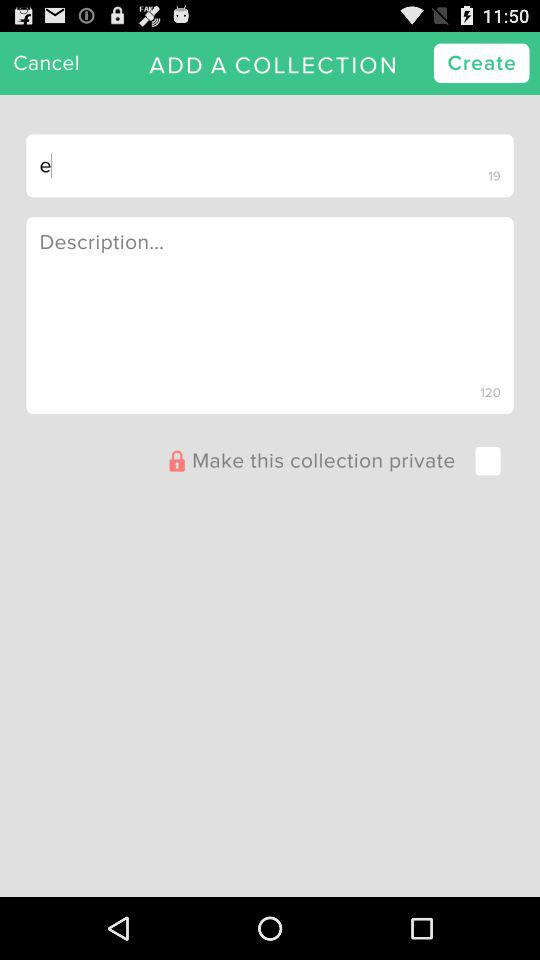What is the status of the "Make this collection private"? The status is off. 